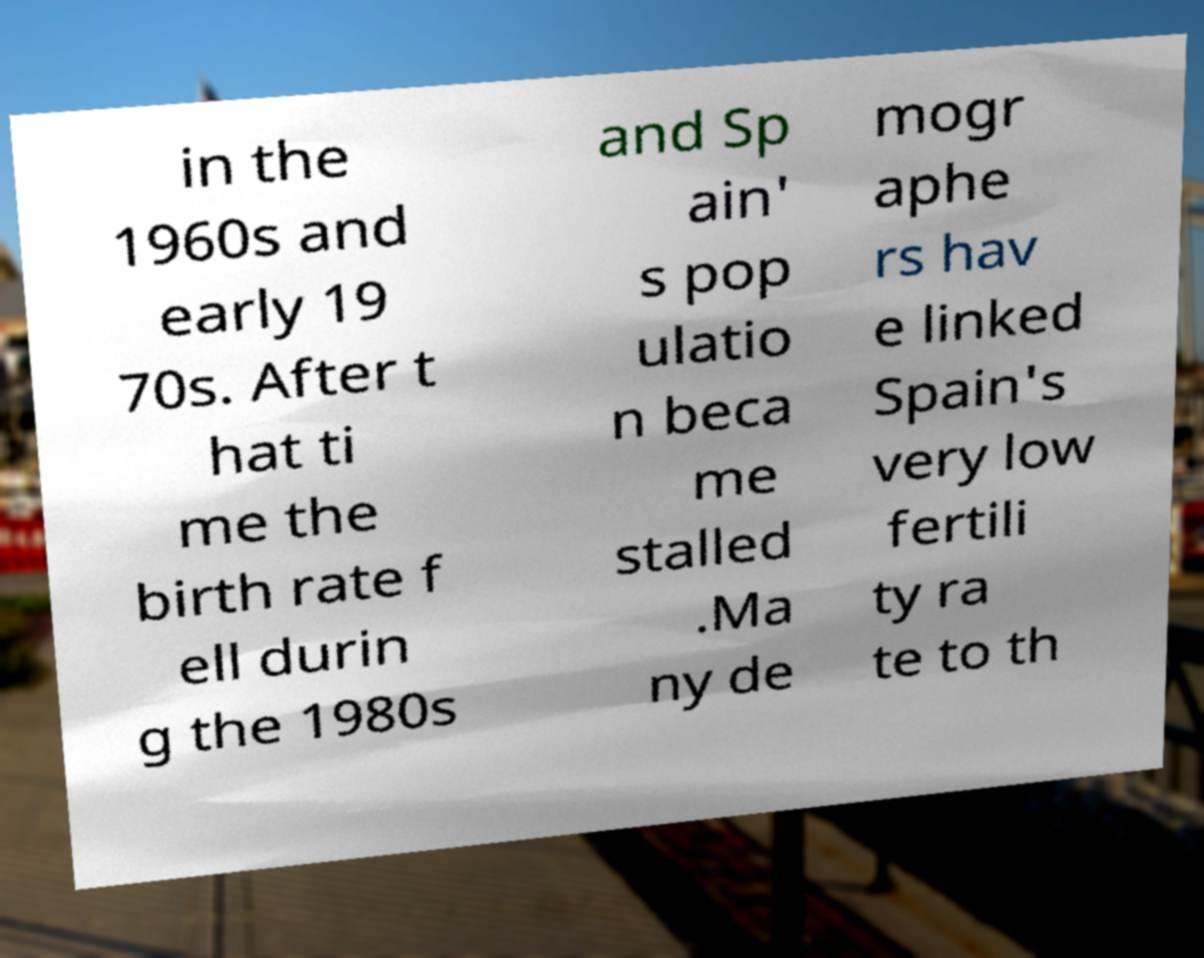There's text embedded in this image that I need extracted. Can you transcribe it verbatim? in the 1960s and early 19 70s. After t hat ti me the birth rate f ell durin g the 1980s and Sp ain' s pop ulatio n beca me stalled .Ma ny de mogr aphe rs hav e linked Spain's very low fertili ty ra te to th 